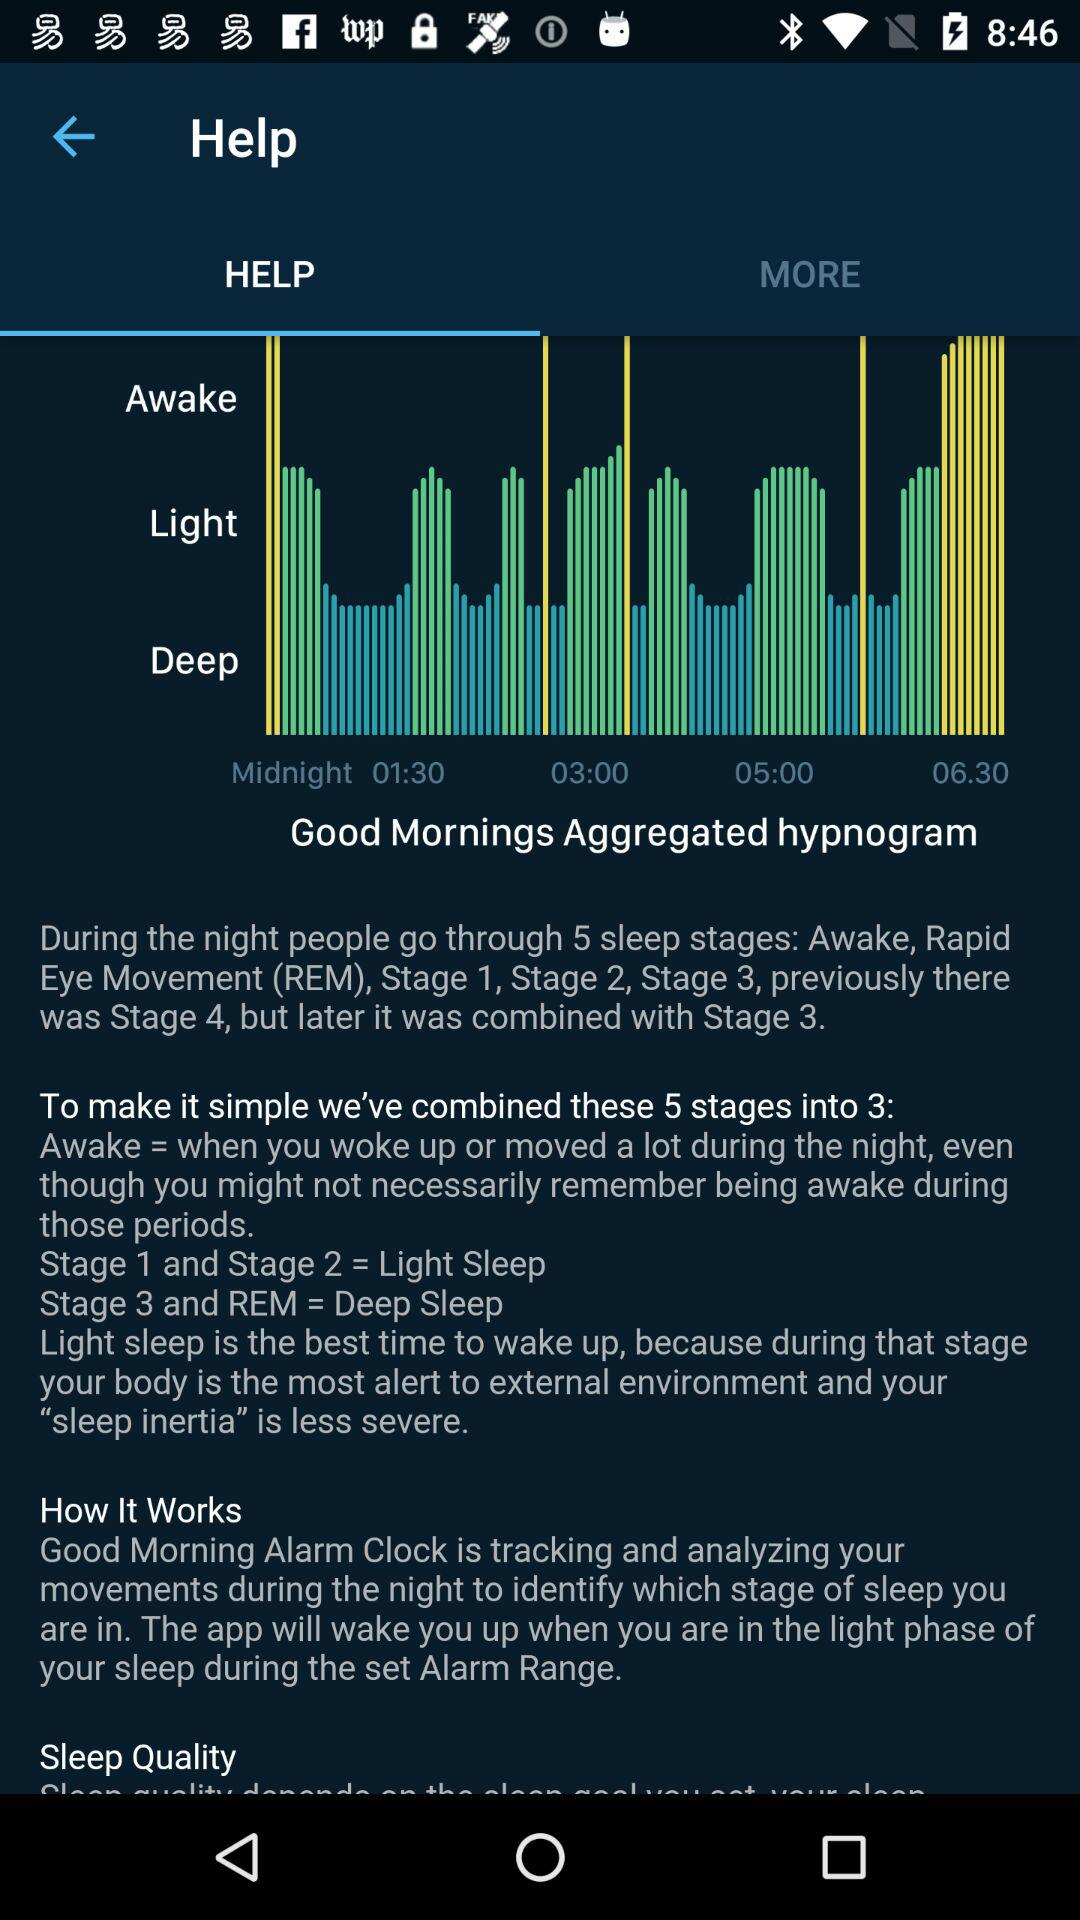What is the best time to wake up? The best time to wake up is "Light sleep". 